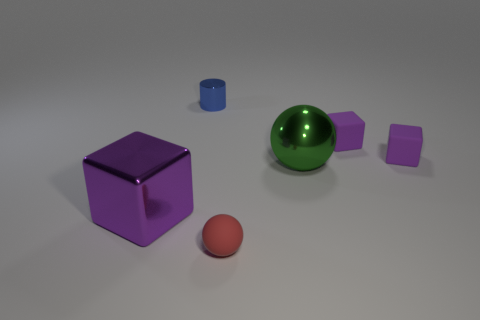Add 1 large cyan blocks. How many objects exist? 7 Subtract all purple matte blocks. How many blocks are left? 1 Subtract all balls. How many objects are left? 4 Add 5 blue objects. How many blue objects are left? 6 Add 5 tiny metallic objects. How many tiny metallic objects exist? 6 Subtract 1 blue cylinders. How many objects are left? 5 Subtract all blue cubes. Subtract all yellow spheres. How many cubes are left? 3 Subtract all large spheres. Subtract all small red matte spheres. How many objects are left? 4 